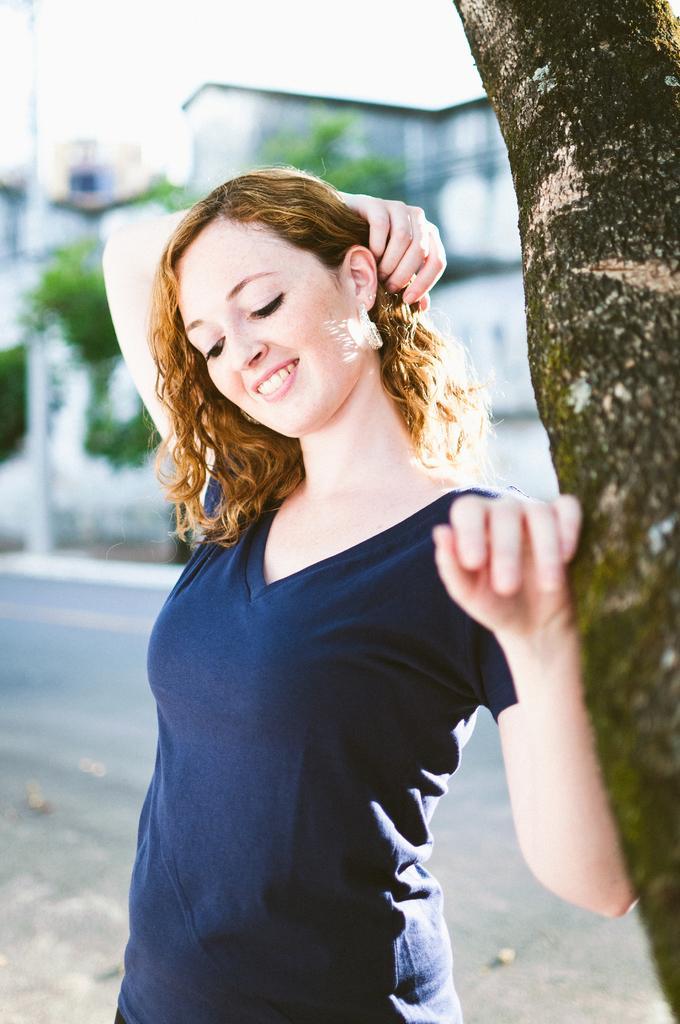How would you summarize this image in a sentence or two? In this image in the middle there is a woman, she wears a t shirt, her hair is short, she is smiling. On the right there is a tree. In the background there are trees, buildings, road and sky. 